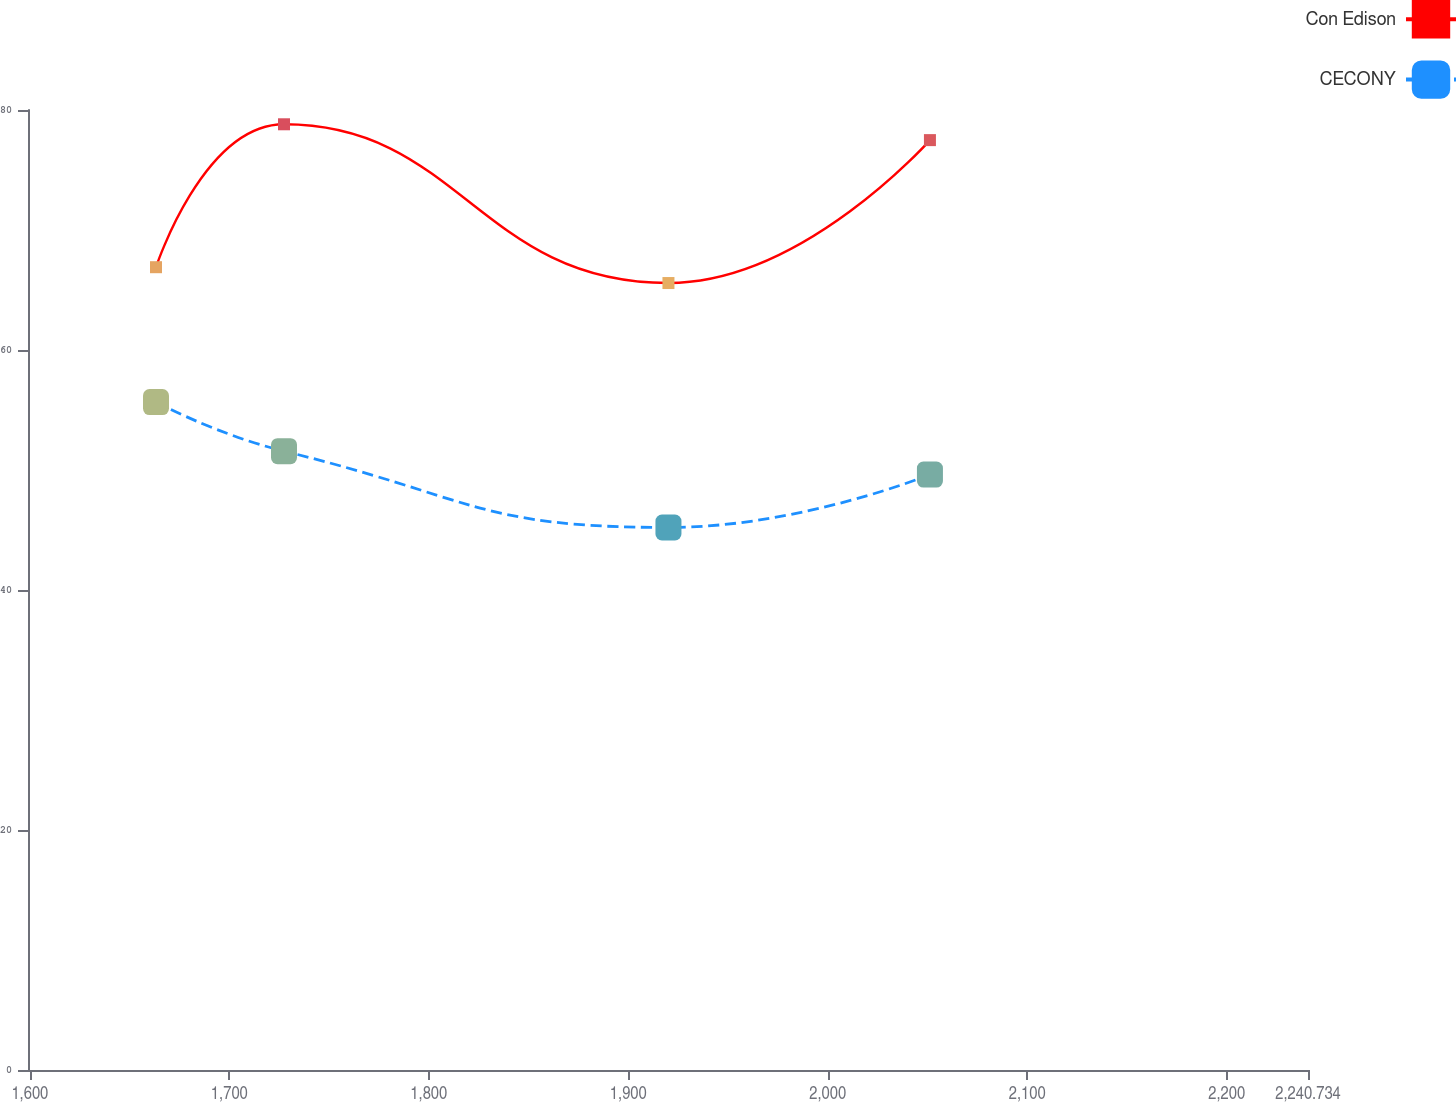Convert chart. <chart><loc_0><loc_0><loc_500><loc_500><line_chart><ecel><fcel>Con Edison<fcel>CECONY<nl><fcel>1663.24<fcel>66.9<fcel>55.66<nl><fcel>1727.41<fcel>78.81<fcel>51.57<nl><fcel>1920.13<fcel>65.58<fcel>45.21<nl><fcel>2051.21<fcel>77.49<fcel>49.62<nl><fcel>2304.9<fcel>72.88<fcel>48.57<nl></chart> 